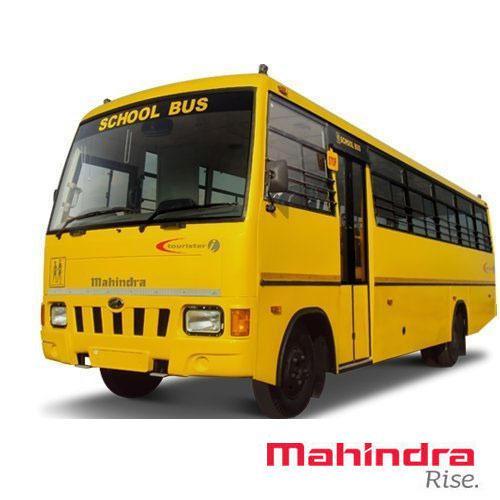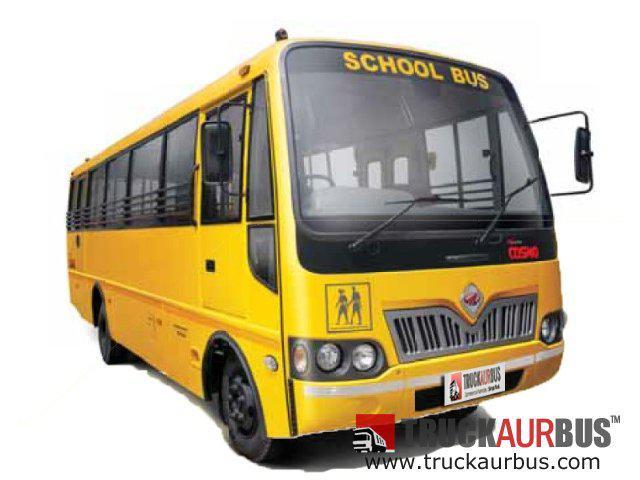The first image is the image on the left, the second image is the image on the right. For the images displayed, is the sentence "The buses in the left and right images face leftward, and neither bus has a driver behind the wheel." factually correct? Answer yes or no. No. The first image is the image on the left, the second image is the image on the right. Analyze the images presented: Is the assertion "Two school buses are angled in the same direction, one with side double doors behind the front tire, and the other with double doors in front of the tire." valid? Answer yes or no. No. 